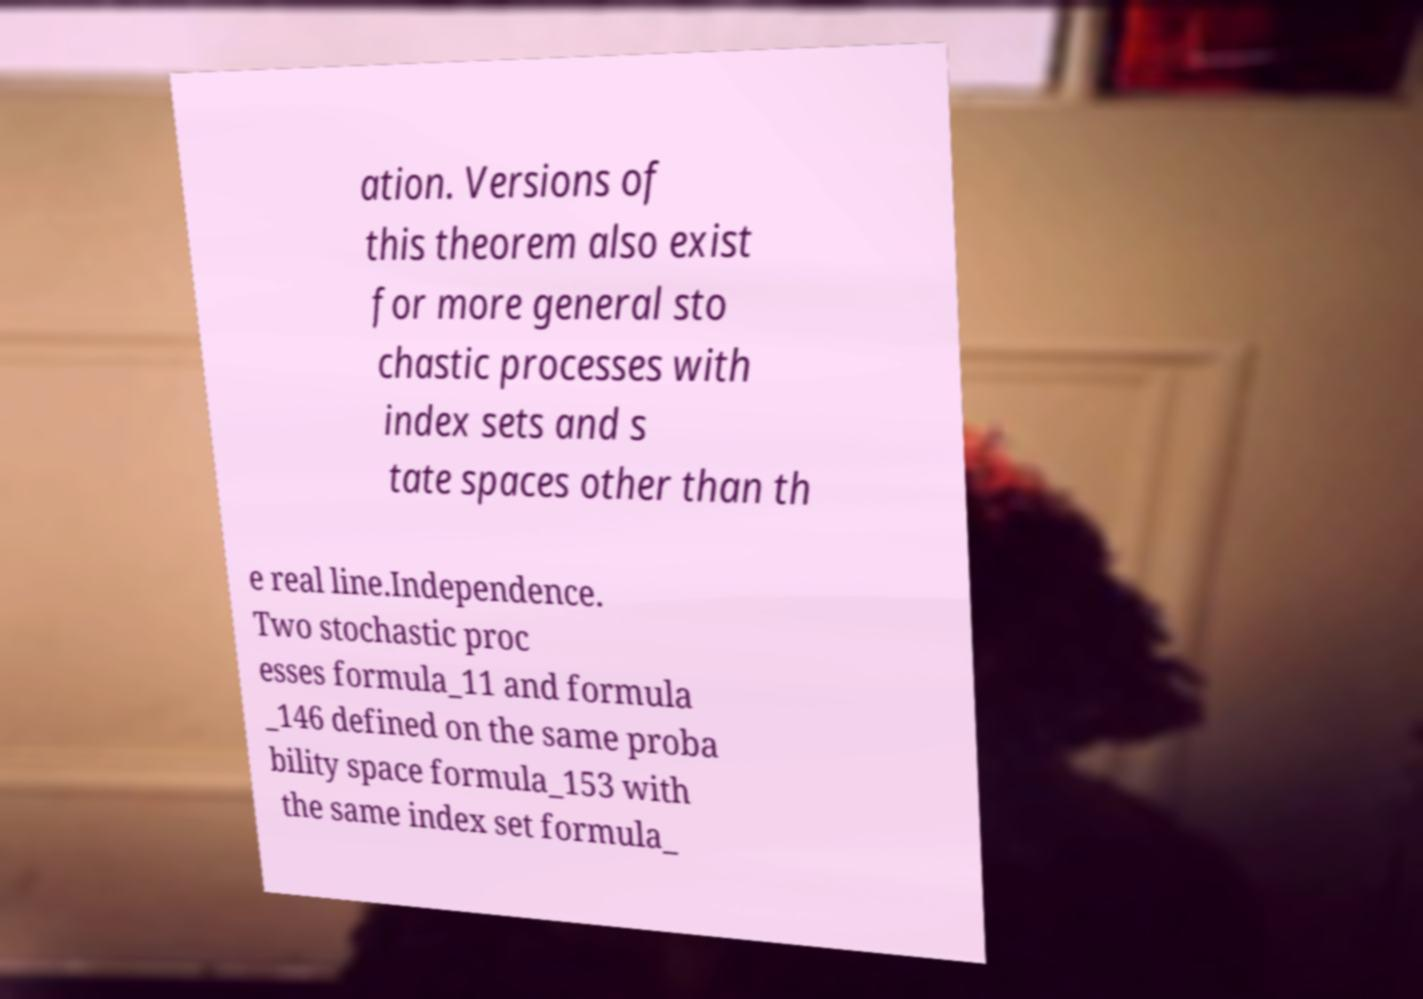Could you extract and type out the text from this image? ation. Versions of this theorem also exist for more general sto chastic processes with index sets and s tate spaces other than th e real line.Independence. Two stochastic proc esses formula_11 and formula _146 defined on the same proba bility space formula_153 with the same index set formula_ 